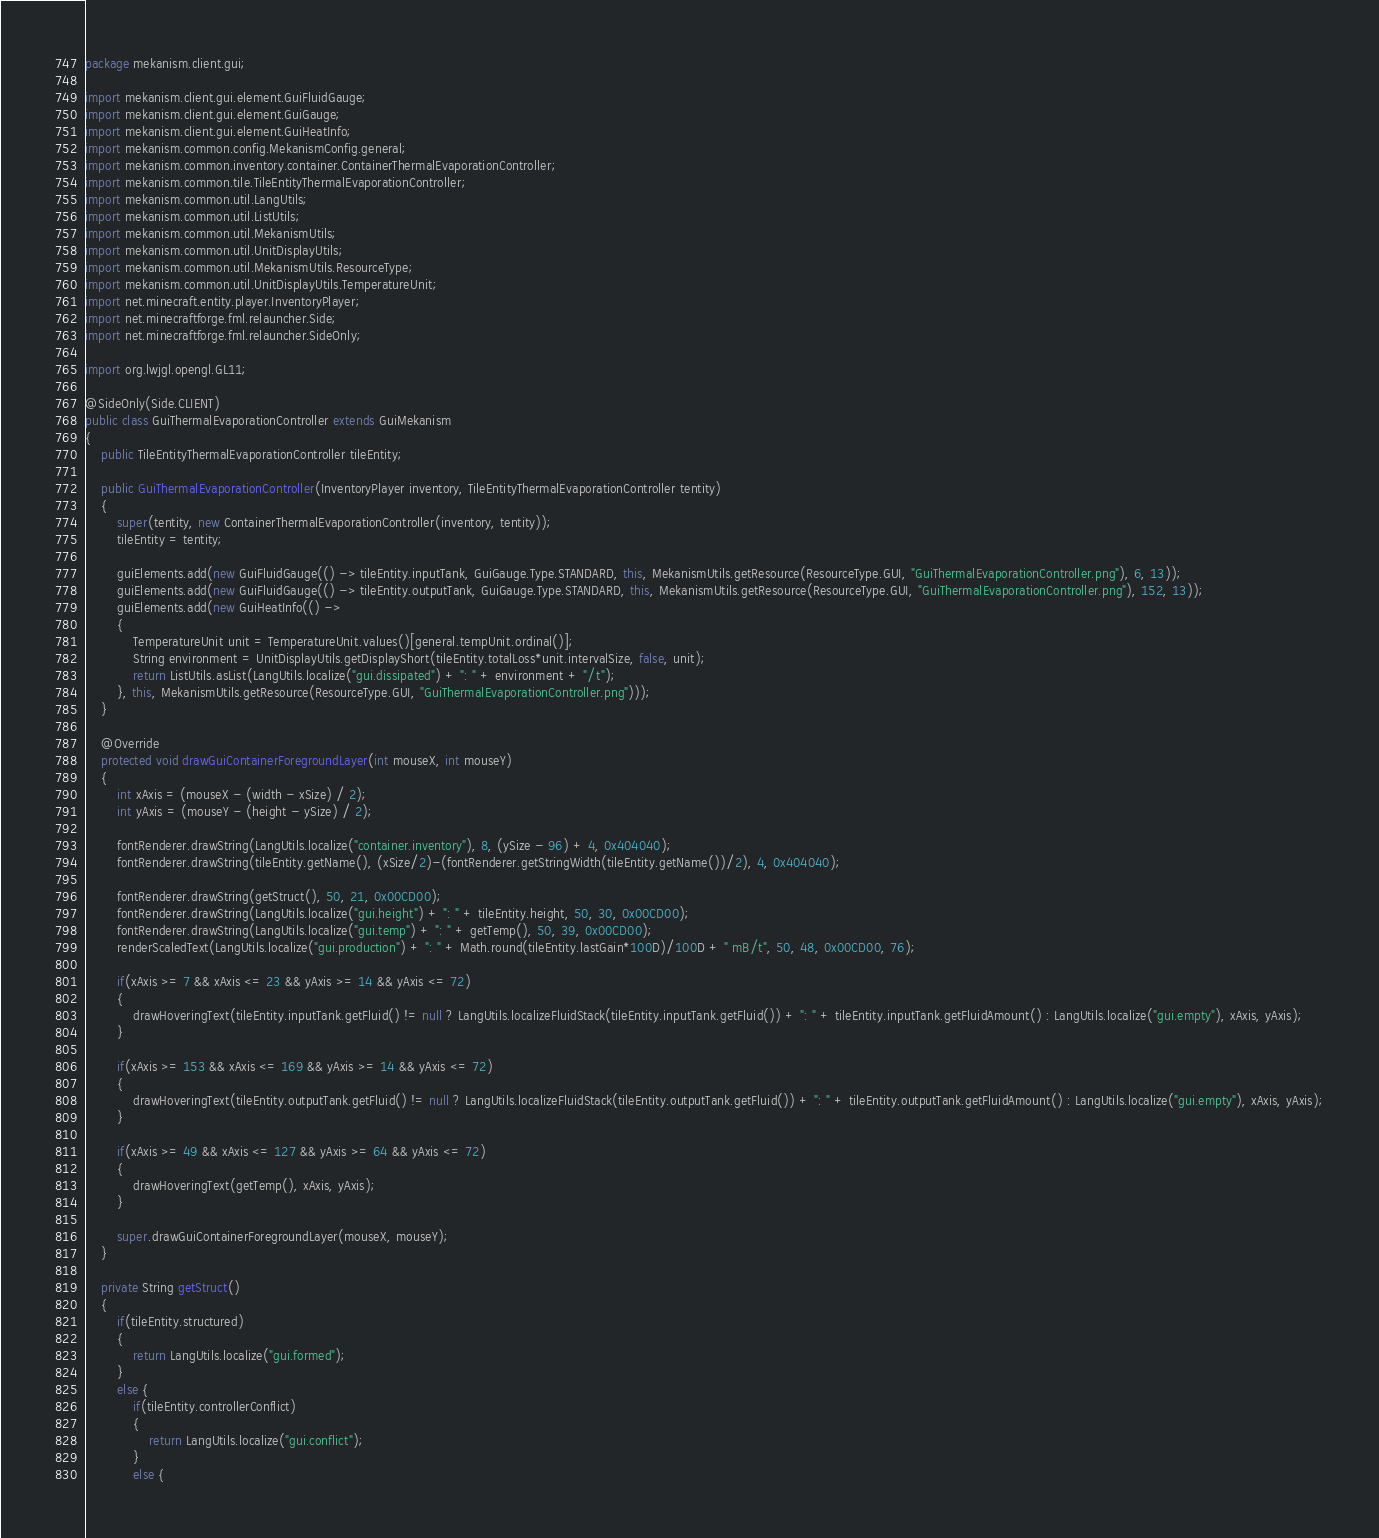Convert code to text. <code><loc_0><loc_0><loc_500><loc_500><_Java_>package mekanism.client.gui;

import mekanism.client.gui.element.GuiFluidGauge;
import mekanism.client.gui.element.GuiGauge;
import mekanism.client.gui.element.GuiHeatInfo;
import mekanism.common.config.MekanismConfig.general;
import mekanism.common.inventory.container.ContainerThermalEvaporationController;
import mekanism.common.tile.TileEntityThermalEvaporationController;
import mekanism.common.util.LangUtils;
import mekanism.common.util.ListUtils;
import mekanism.common.util.MekanismUtils;
import mekanism.common.util.UnitDisplayUtils;
import mekanism.common.util.MekanismUtils.ResourceType;
import mekanism.common.util.UnitDisplayUtils.TemperatureUnit;
import net.minecraft.entity.player.InventoryPlayer;
import net.minecraftforge.fml.relauncher.Side;
import net.minecraftforge.fml.relauncher.SideOnly;

import org.lwjgl.opengl.GL11;

@SideOnly(Side.CLIENT)
public class GuiThermalEvaporationController extends GuiMekanism
{
	public TileEntityThermalEvaporationController tileEntity;

	public GuiThermalEvaporationController(InventoryPlayer inventory, TileEntityThermalEvaporationController tentity)
	{
		super(tentity, new ContainerThermalEvaporationController(inventory, tentity));
		tileEntity = tentity;
		
		guiElements.add(new GuiFluidGauge(() -> tileEntity.inputTank, GuiGauge.Type.STANDARD, this, MekanismUtils.getResource(ResourceType.GUI, "GuiThermalEvaporationController.png"), 6, 13));
		guiElements.add(new GuiFluidGauge(() -> tileEntity.outputTank, GuiGauge.Type.STANDARD, this, MekanismUtils.getResource(ResourceType.GUI, "GuiThermalEvaporationController.png"), 152, 13));
		guiElements.add(new GuiHeatInfo(() ->
		{
            TemperatureUnit unit = TemperatureUnit.values()[general.tempUnit.ordinal()];
            String environment = UnitDisplayUtils.getDisplayShort(tileEntity.totalLoss*unit.intervalSize, false, unit);
            return ListUtils.asList(LangUtils.localize("gui.dissipated") + ": " + environment + "/t");
        }, this, MekanismUtils.getResource(ResourceType.GUI, "GuiThermalEvaporationController.png")));
	}

	@Override
	protected void drawGuiContainerForegroundLayer(int mouseX, int mouseY)
	{
		int xAxis = (mouseX - (width - xSize) / 2);
		int yAxis = (mouseY - (height - ySize) / 2);

		fontRenderer.drawString(LangUtils.localize("container.inventory"), 8, (ySize - 96) + 4, 0x404040);
		fontRenderer.drawString(tileEntity.getName(), (xSize/2)-(fontRenderer.getStringWidth(tileEntity.getName())/2), 4, 0x404040);

		fontRenderer.drawString(getStruct(), 50, 21, 0x00CD00);
		fontRenderer.drawString(LangUtils.localize("gui.height") + ": " + tileEntity.height, 50, 30, 0x00CD00);
		fontRenderer.drawString(LangUtils.localize("gui.temp") + ": " + getTemp(), 50, 39, 0x00CD00);
		renderScaledText(LangUtils.localize("gui.production") + ": " + Math.round(tileEntity.lastGain*100D)/100D + " mB/t", 50, 48, 0x00CD00, 76);

		if(xAxis >= 7 && xAxis <= 23 && yAxis >= 14 && yAxis <= 72)
		{
			drawHoveringText(tileEntity.inputTank.getFluid() != null ? LangUtils.localizeFluidStack(tileEntity.inputTank.getFluid()) + ": " + tileEntity.inputTank.getFluidAmount() : LangUtils.localize("gui.empty"), xAxis, yAxis);
		}

		if(xAxis >= 153 && xAxis <= 169 && yAxis >= 14 && yAxis <= 72)
		{
			drawHoveringText(tileEntity.outputTank.getFluid() != null ? LangUtils.localizeFluidStack(tileEntity.outputTank.getFluid()) + ": " + tileEntity.outputTank.getFluidAmount() : LangUtils.localize("gui.empty"), xAxis, yAxis);
		}

		if(xAxis >= 49 && xAxis <= 127 && yAxis >= 64 && yAxis <= 72)
		{
			drawHoveringText(getTemp(), xAxis, yAxis);
		}

		super.drawGuiContainerForegroundLayer(mouseX, mouseY);
	}

	private String getStruct()
	{
		if(tileEntity.structured)
		{
			return LangUtils.localize("gui.formed");
		}
		else {
			if(tileEntity.controllerConflict)
			{
				return LangUtils.localize("gui.conflict");
			}
			else {</code> 